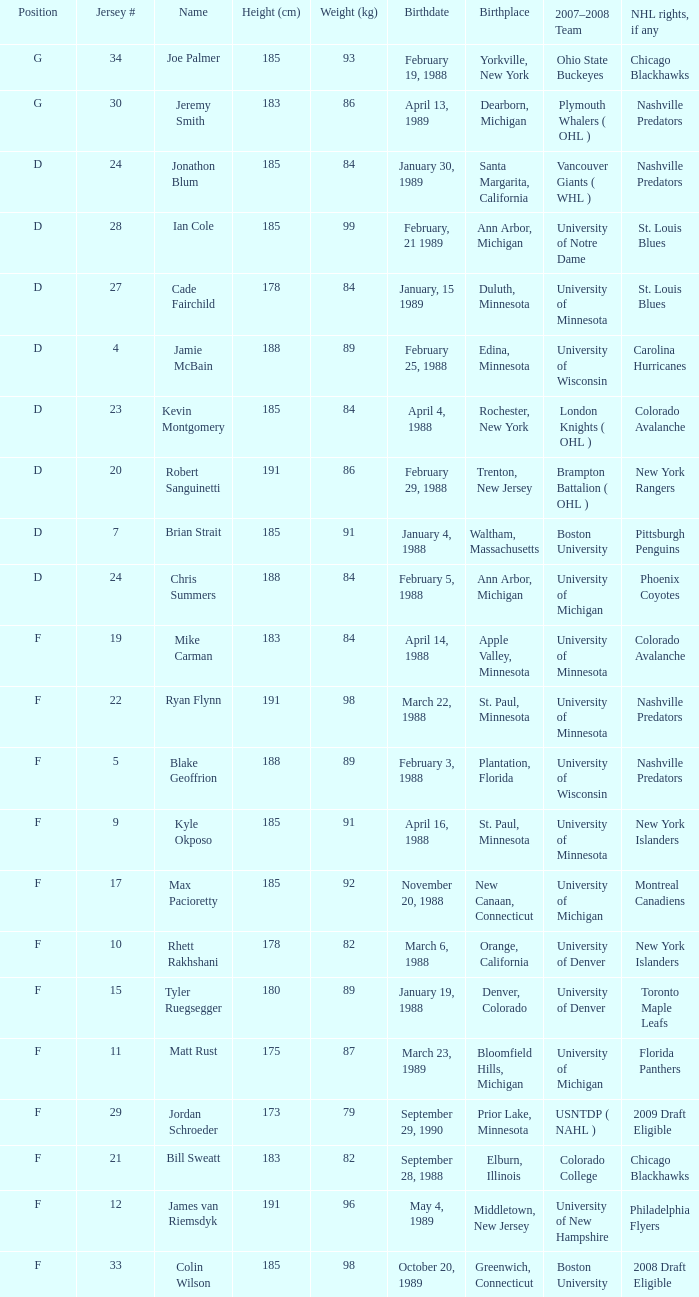What is the weight (kg) of a nhl player with phoenix coyotes rights, if any? 1.0. 